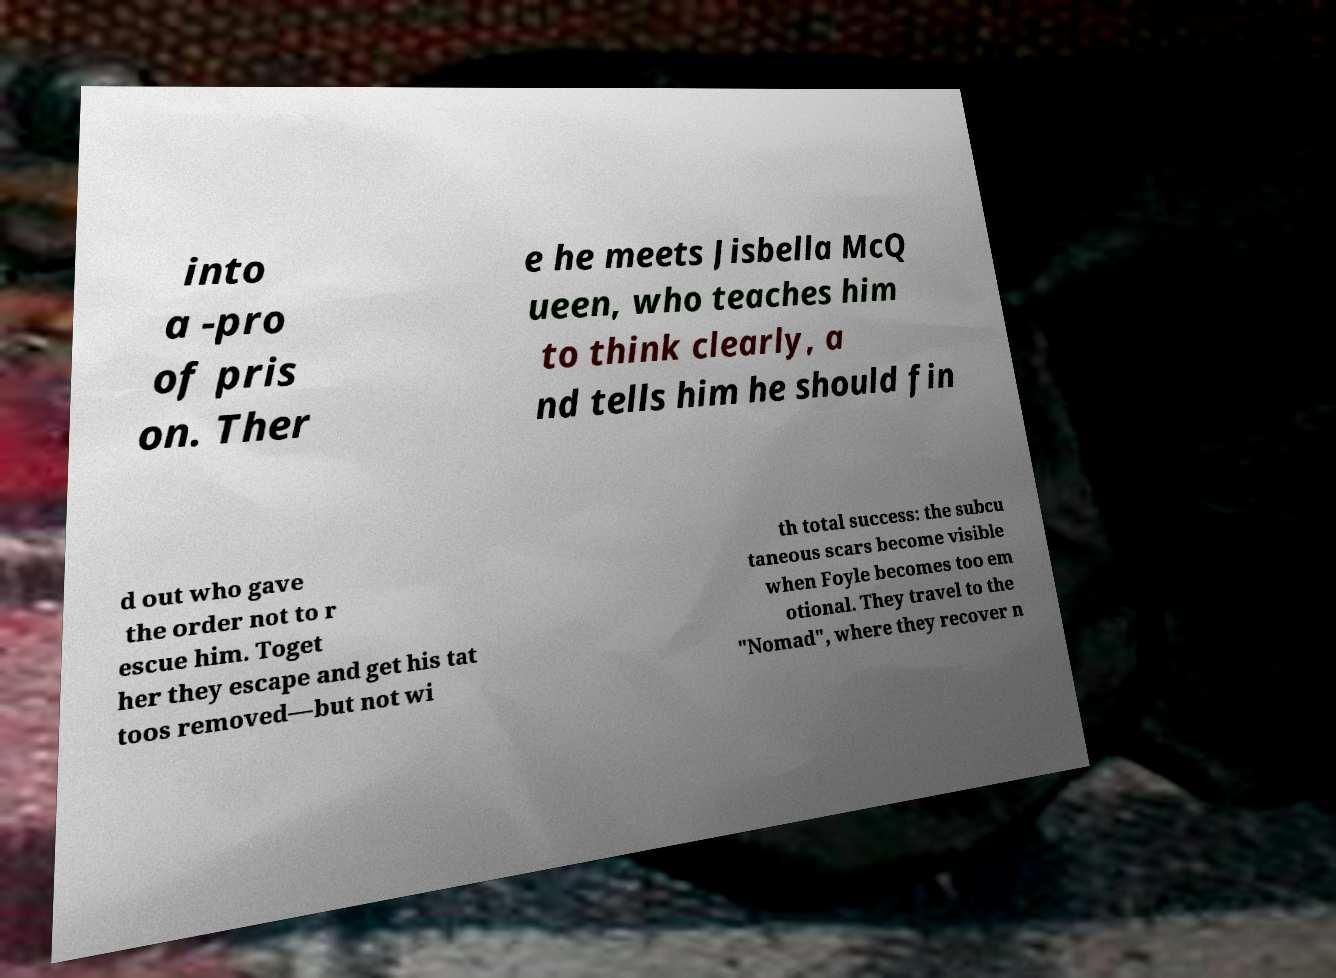For documentation purposes, I need the text within this image transcribed. Could you provide that? into a -pro of pris on. Ther e he meets Jisbella McQ ueen, who teaches him to think clearly, a nd tells him he should fin d out who gave the order not to r escue him. Toget her they escape and get his tat toos removed—but not wi th total success: the subcu taneous scars become visible when Foyle becomes too em otional. They travel to the "Nomad", where they recover n 